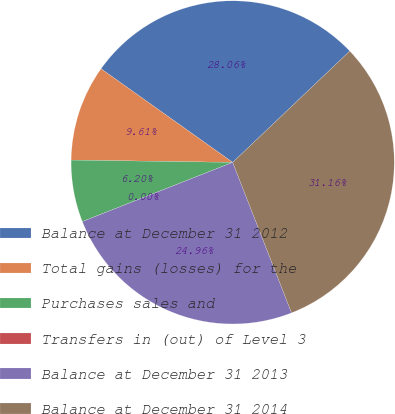Convert chart to OTSL. <chart><loc_0><loc_0><loc_500><loc_500><pie_chart><fcel>Balance at December 31 2012<fcel>Total gains (losses) for the<fcel>Purchases sales and<fcel>Transfers in (out) of Level 3<fcel>Balance at December 31 2013<fcel>Balance at December 31 2014<nl><fcel>28.06%<fcel>9.61%<fcel>6.2%<fcel>0.0%<fcel>24.96%<fcel>31.16%<nl></chart> 